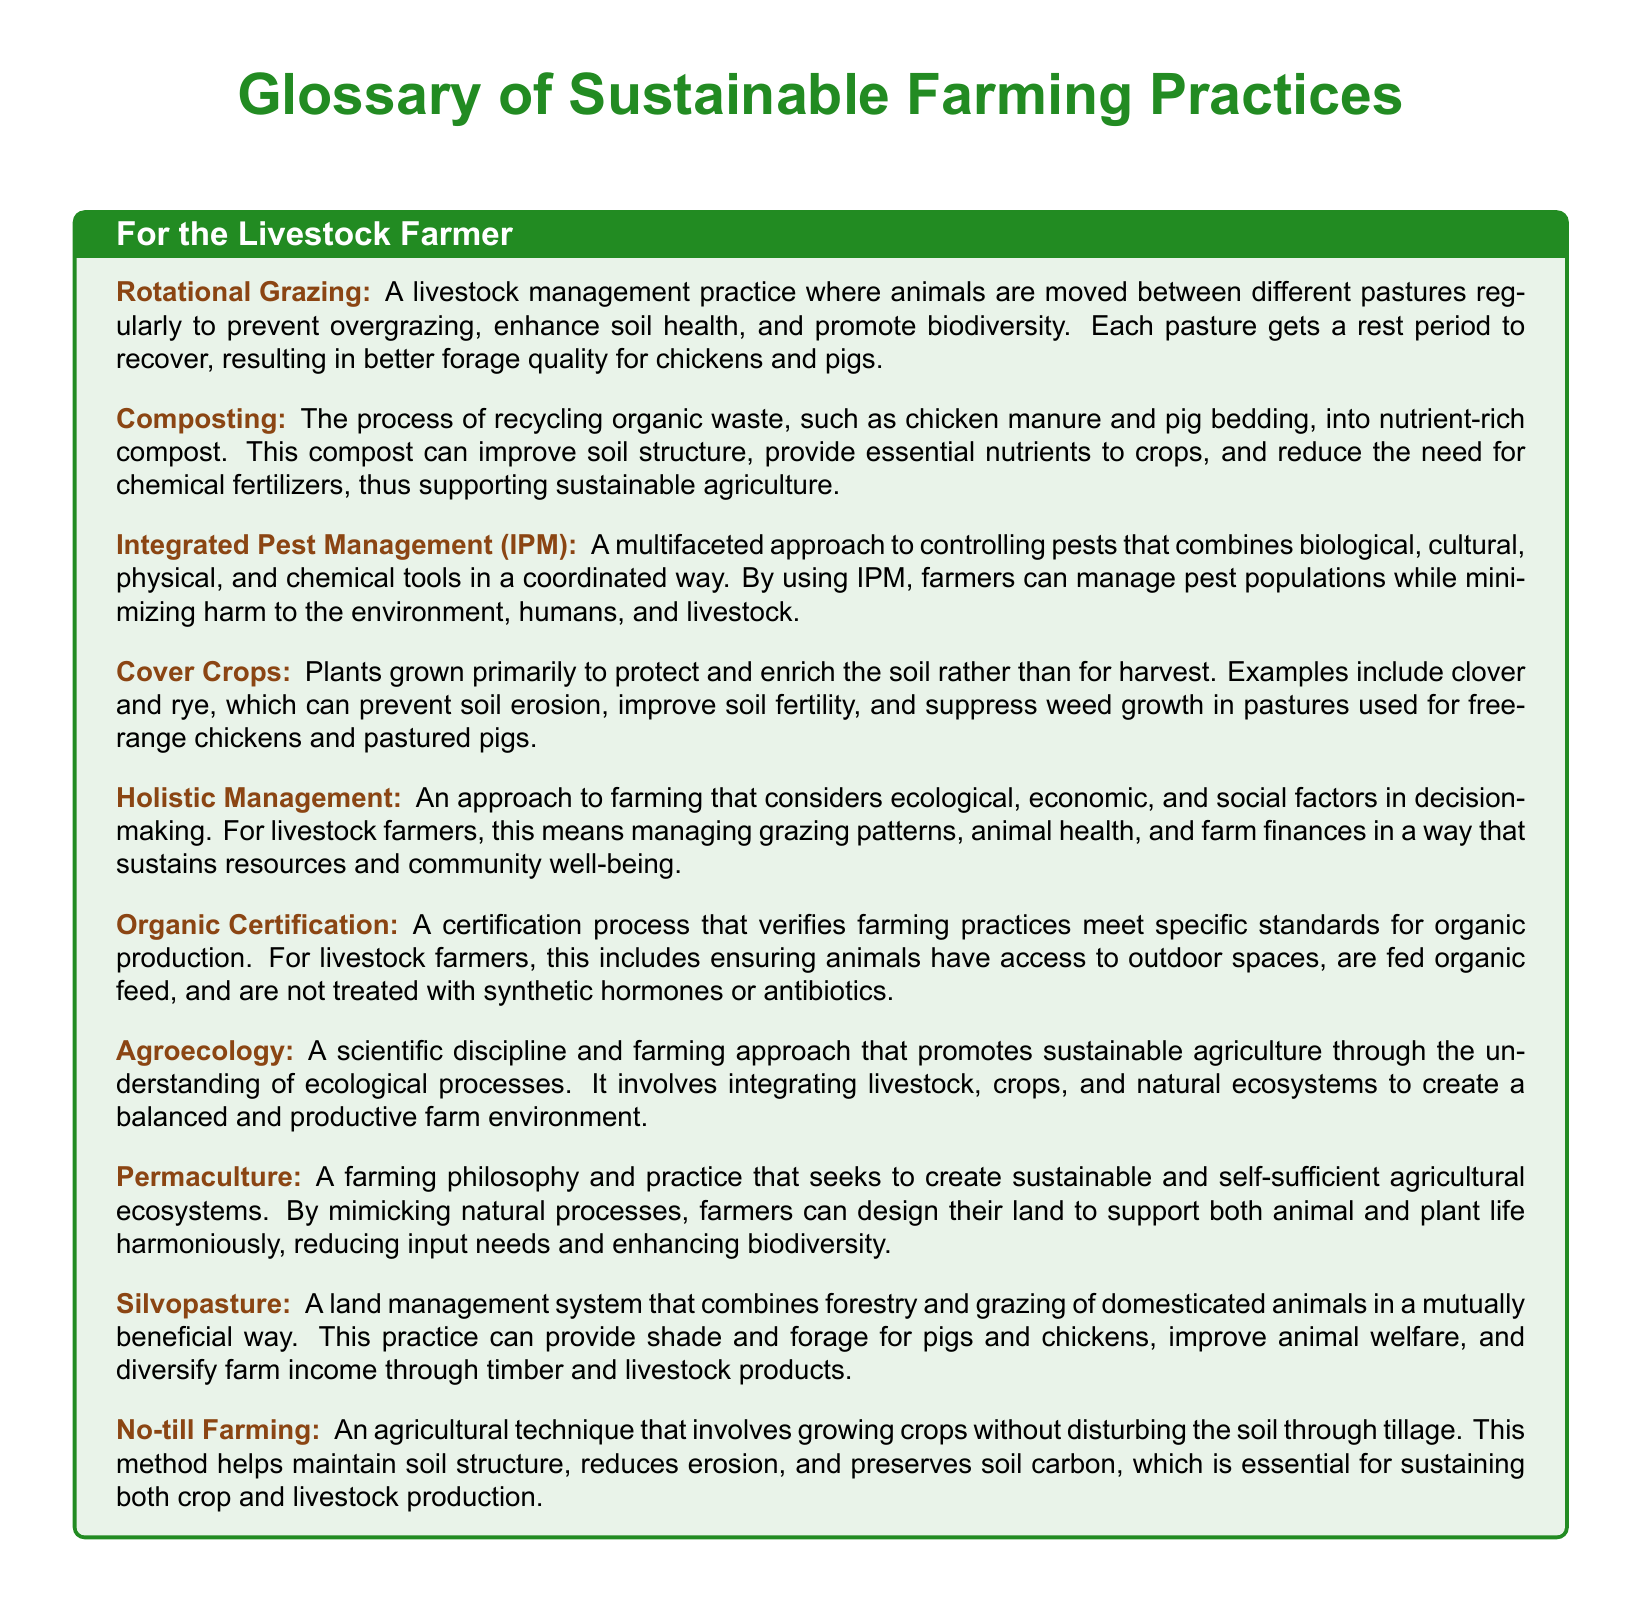What is rotational grazing? Rotational grazing is defined as a livestock management practice where animals are moved between different pastures regularly to prevent overgrazing.
Answer: A livestock management practice What is composting used for? Composting is a process that recycles organic waste into nutrient-rich compost, which can improve soil structure.
Answer: Improve soil structure What does IPM stand for? The abbreviation IPM refers to Integrated Pest Management, which is a multifaceted approach to controlling pests.
Answer: Integrated Pest Management What is the role of cover crops? Cover crops are primarily grown to protect and enrich the soil rather than for harvest.
Answer: Protect and enrich the soil What does organic certification ensure? Organic certification ensures that farming practices meet specific standards for organic production.
Answer: Specific standards for organic production How is holistic management defined in farming? Holistic management is an approach that considers ecological, economic, and social factors in decision-making.
Answer: Consider ecological, economic, and social factors What is agroecology? Agroecology is a scientific discipline and farming approach that promotes sustainable agriculture through understanding ecological processes.
Answer: Sustainable agriculture What is silvopasture? Silvopasture is a land management system that combines forestry and grazing of domesticated animals.
Answer: A land management system What does no-till farming help maintain? No-till farming helps maintain soil structure by growing crops without disturbing the soil through tillage.
Answer: Soil structure 